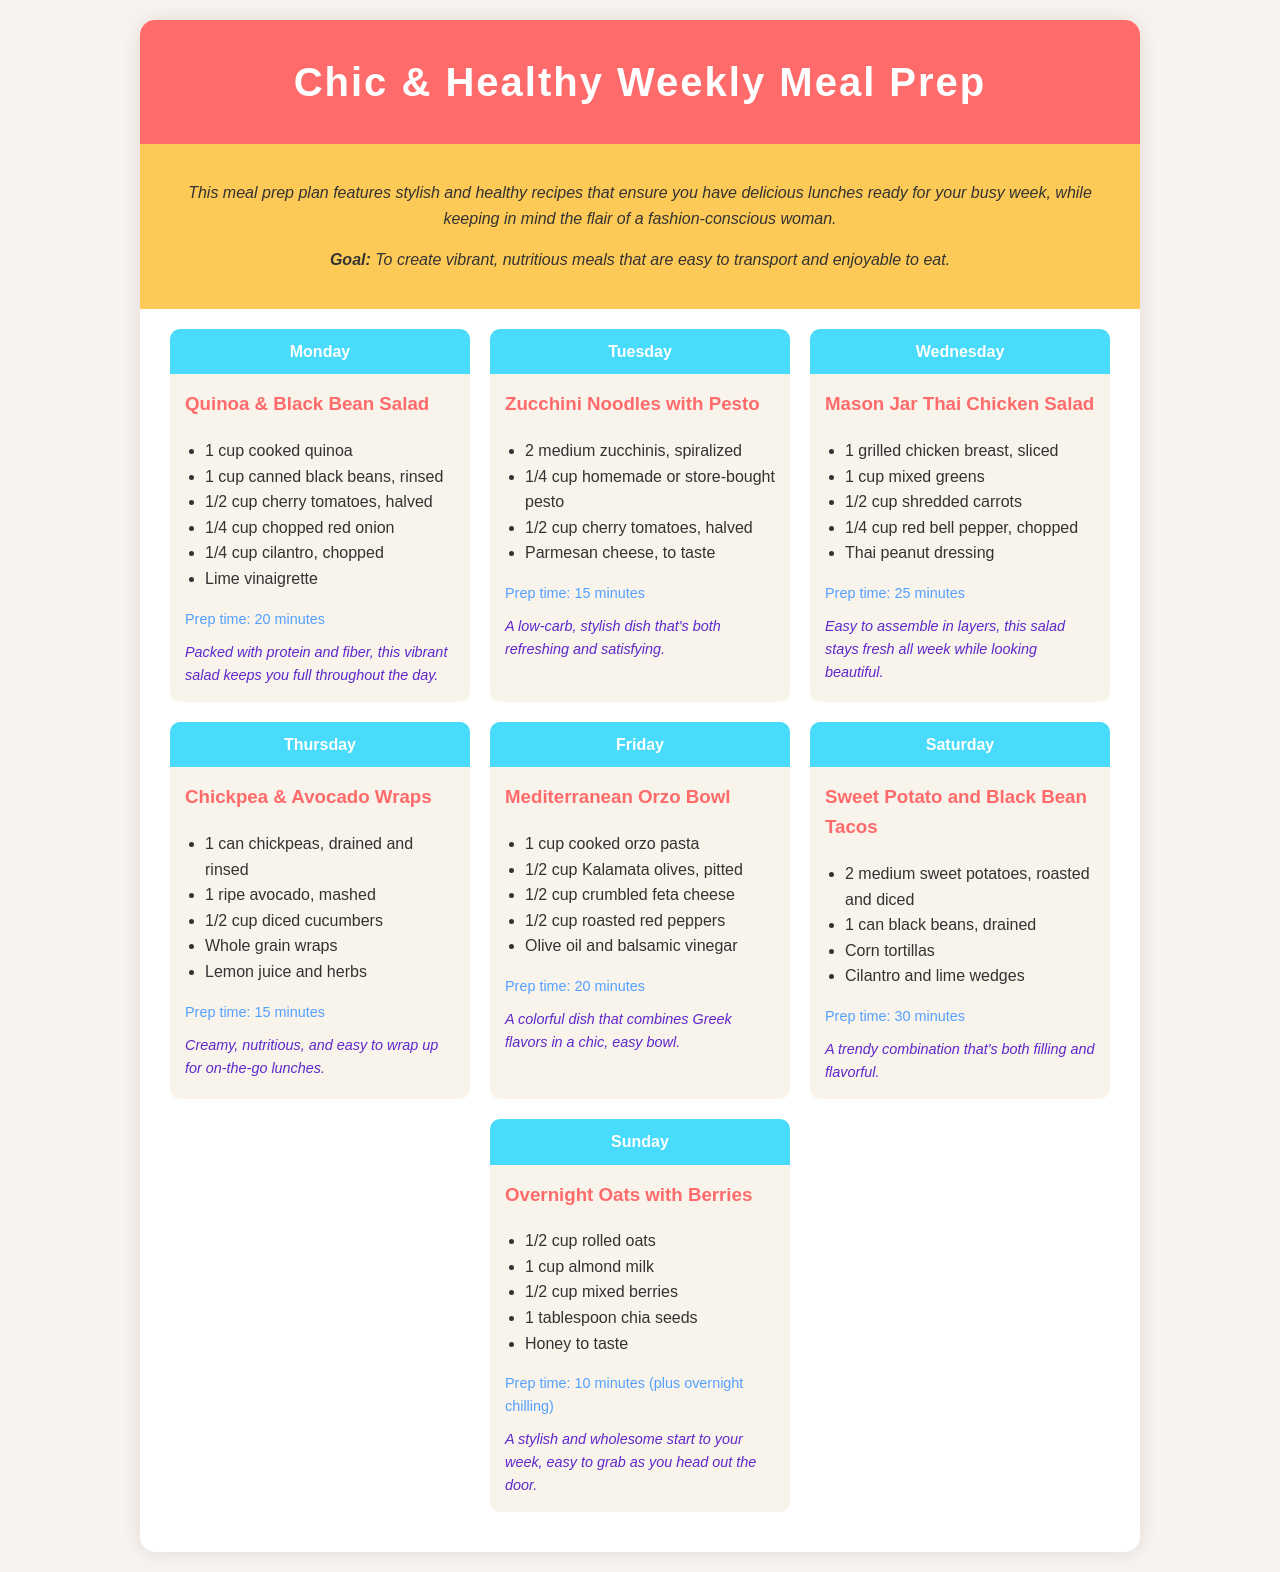What is the title of the document? The title is prominently displayed in the header of the document.
Answer: Chic & Healthy Weekly Meal Prep What day features the Zucchini Noodles with Pesto? The days of the week are listed alongside the corresponding meal details.
Answer: Tuesday How many minutes does it take to prepare the Overnight Oats with Berries? The prep time is listed for each meal, including this one.
Answer: 10 minutes Which meal is prepared on Wednesday? The meals for each day are detailed in individual sections.
Answer: Mason Jar Thai Chicken Salad What primary ingredient is used in the Chickpea & Avocado Wraps? The ingredients are listed under each meal heading.
Answer: Chickpeas What is the benefit of the Quinoa & Black Bean Salad? The benefits of each dish are provided to highlight their positive aspects.
Answer: Packed with protein and fiber What is the total number of meals listed in the schedule? Counting the individual meal entries gives the total number.
Answer: 7 meals On which day do we prepare Sweet Potato and Black Bean Tacos? The schedule specifies daily meals, making this easy to find.
Answer: Saturday 